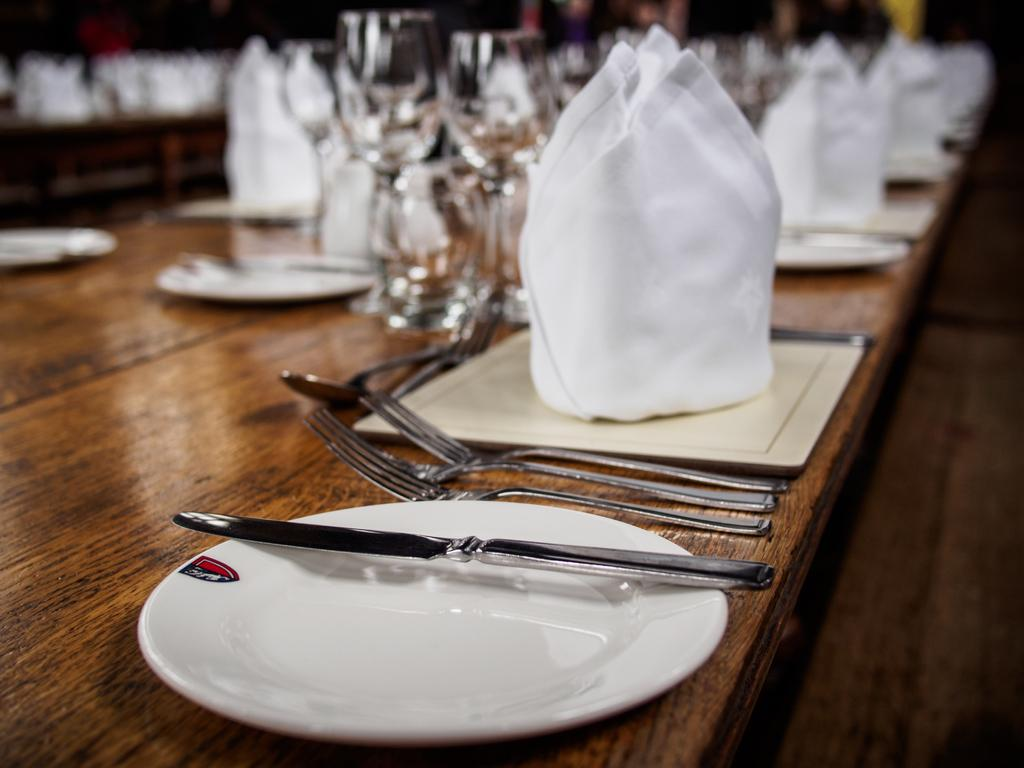What is located in the center of the image? There is a table in the center of the image. What items can be seen on the table? There are glasses, tissues, a cloth, and spoons on the table. Is there anything in the foreground of the image? Yes, there is a plate in the foreground of the image. What is on the plate? There is a knife on the plate. What is the rate at which the flesh is being consumed in the image? There is no flesh present in the image, so it is not possible to determine a rate of consumption. 